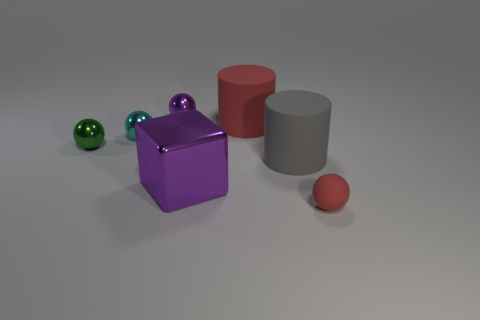Do the red cylinder and the green metallic thing have the same size?
Provide a short and direct response. No. There is a metallic ball that is on the left side of the cyan metallic ball; what color is it?
Give a very brief answer. Green. There is a purple thing to the right of the purple metal object that is behind the cylinder in front of the tiny green metal thing; what is its material?
Ensure brevity in your answer.  Metal. Is there another large object that has the same shape as the gray object?
Your response must be concise. Yes. There is a red thing that is the same size as the cyan object; what is its shape?
Offer a very short reply. Sphere. What number of large objects are both to the right of the large cube and in front of the green object?
Provide a succinct answer. 1. Are there fewer metallic blocks on the left side of the gray thing than green spheres?
Offer a terse response. No. Are there any purple metallic blocks that have the same size as the gray rubber cylinder?
Provide a short and direct response. Yes. There is a block that is made of the same material as the small green sphere; what is its color?
Make the answer very short. Purple. What number of big red rubber objects are left of the red thing behind the big gray rubber cylinder?
Your answer should be compact. 0. 